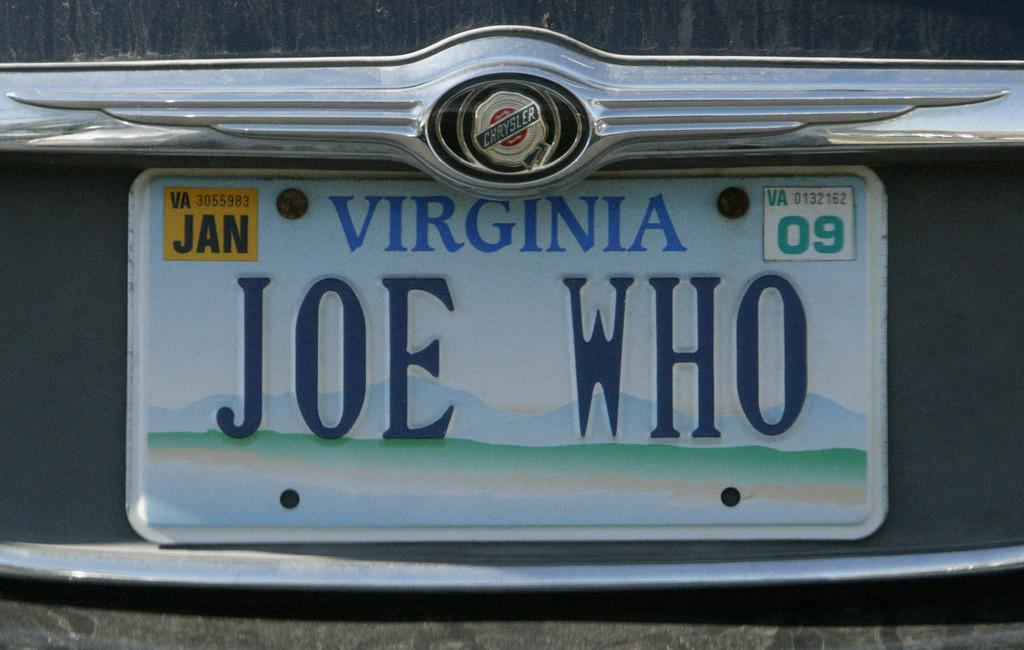<image>
Summarize the visual content of the image. Virginia licence plate which says Joe on it. 